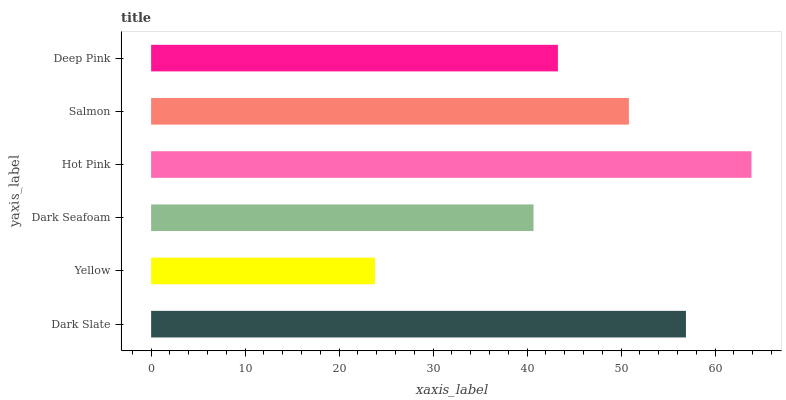Is Yellow the minimum?
Answer yes or no. Yes. Is Hot Pink the maximum?
Answer yes or no. Yes. Is Dark Seafoam the minimum?
Answer yes or no. No. Is Dark Seafoam the maximum?
Answer yes or no. No. Is Dark Seafoam greater than Yellow?
Answer yes or no. Yes. Is Yellow less than Dark Seafoam?
Answer yes or no. Yes. Is Yellow greater than Dark Seafoam?
Answer yes or no. No. Is Dark Seafoam less than Yellow?
Answer yes or no. No. Is Salmon the high median?
Answer yes or no. Yes. Is Deep Pink the low median?
Answer yes or no. Yes. Is Deep Pink the high median?
Answer yes or no. No. Is Dark Slate the low median?
Answer yes or no. No. 